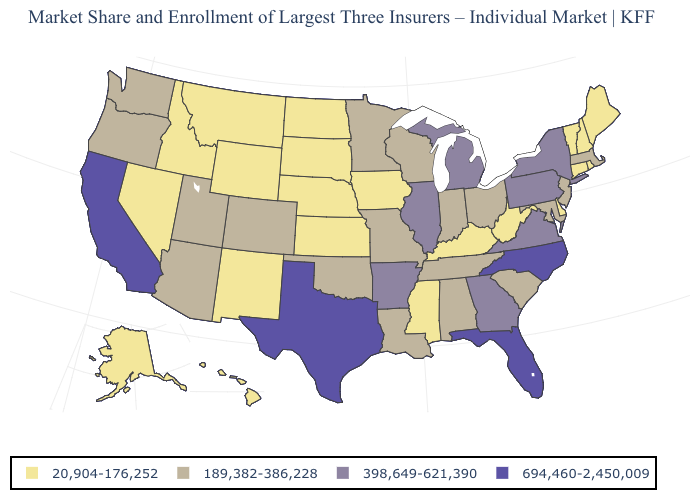Name the states that have a value in the range 189,382-386,228?
Answer briefly. Alabama, Arizona, Colorado, Indiana, Louisiana, Maryland, Massachusetts, Minnesota, Missouri, New Jersey, Ohio, Oklahoma, Oregon, South Carolina, Tennessee, Utah, Washington, Wisconsin. Name the states that have a value in the range 694,460-2,450,009?
Answer briefly. California, Florida, North Carolina, Texas. How many symbols are there in the legend?
Give a very brief answer. 4. What is the value of Alabama?
Answer briefly. 189,382-386,228. Which states have the lowest value in the USA?
Concise answer only. Alaska, Connecticut, Delaware, Hawaii, Idaho, Iowa, Kansas, Kentucky, Maine, Mississippi, Montana, Nebraska, Nevada, New Hampshire, New Mexico, North Dakota, Rhode Island, South Dakota, Vermont, West Virginia, Wyoming. Does the first symbol in the legend represent the smallest category?
Concise answer only. Yes. What is the value of Florida?
Concise answer only. 694,460-2,450,009. Among the states that border Idaho , does Nevada have the lowest value?
Keep it brief. Yes. What is the highest value in states that border Kentucky?
Keep it brief. 398,649-621,390. What is the value of Arizona?
Keep it brief. 189,382-386,228. What is the value of Iowa?
Be succinct. 20,904-176,252. Does the map have missing data?
Be succinct. No. How many symbols are there in the legend?
Quick response, please. 4. Among the states that border Connecticut , does Rhode Island have the lowest value?
Answer briefly. Yes. Is the legend a continuous bar?
Answer briefly. No. 